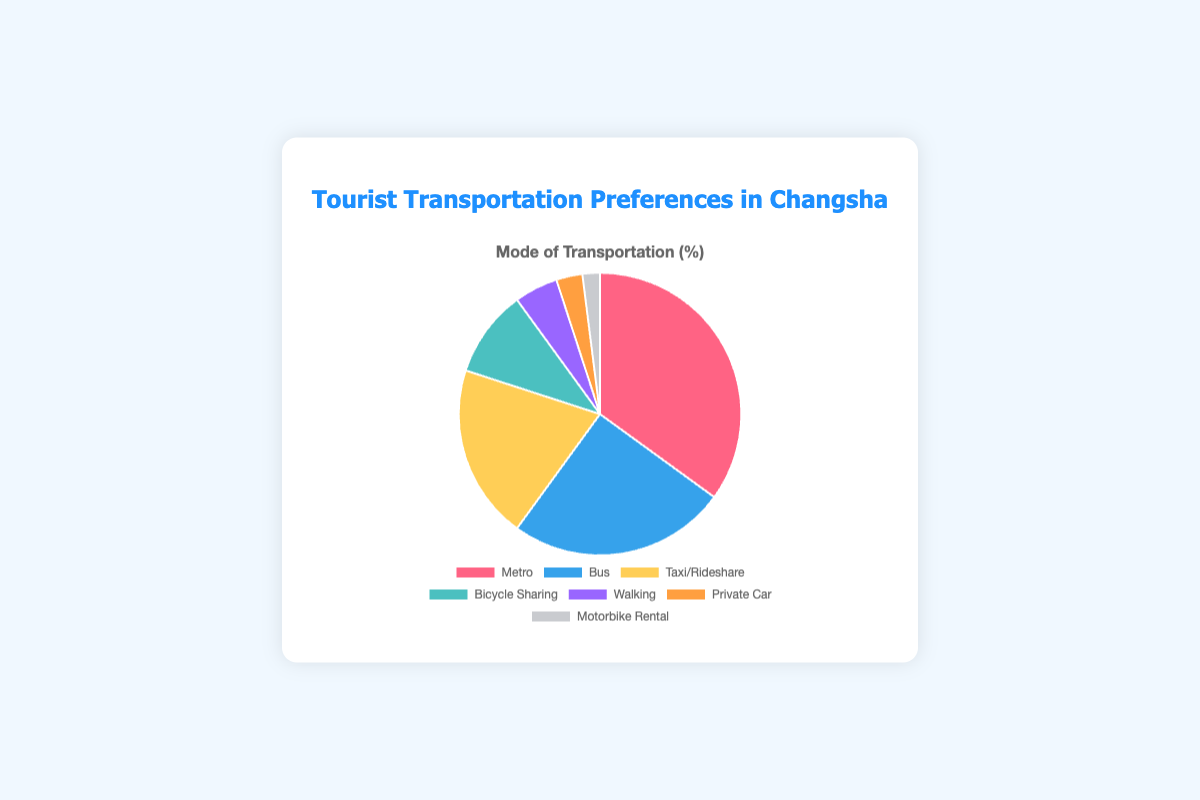What percentage of tourists use Metro and Bus combined? Add the percentage for Metro (35%) and Bus (25%): 35 + 25 = 60.
Answer: 60% Which mode of transportation is least preferred by tourists? Look for the transportation mode with the smallest percentage. Motorbike Rental has the smallest percentage at 2%.
Answer: Motorbike Rental Which transportation mode has a higher percentage, Taxi/Rideshare or Bus? Compare the percentages: Taxi/Rideshare (20%) and Bus (25%). Bus has a higher percentage.
Answer: Bus How much more popular is Metro compared to Walking? Subtract the percentage for Walking (5%) from the percentage for Metro (35%): 35 - 5 = 30.
Answer: 30% What is the combined percentage of tourists using either Metro, Bus, or Taxi/Rideshare? Add the percentages for Metro (35%), Bus (25%), and Taxi/Rideshare (20%): 35 + 25 + 20 = 80.
Answer: 80% Is the percentage of tourists using Private Car greater than those using Bicycle Sharing? Compare the percentages: Private Car (3%) and Bicycle Sharing (10%). Bicycle Sharing has a higher percentage.
Answer: No What percentage of tourists use modes of transportation other than Metro and Bus? First, find the combined percentage for Metro and Bus (35% + 25% = 60%). Then, subtract from 100%: 100 - 60 = 40.
Answer: 40% How does the popularity of Bicycle Sharing compare to Walking? Bicycle Sharing has a percentage of 10%, while Walking has 5%. Bicycle Sharing is twice as popular as Walking.
Answer: Bicycle Sharing is more popular If you were to group Private Car and Motorbike Rental into a single "Private Transport" category, what would its percentage be? Add the percentages for Private Car (3%) and Motorbike Rental (2%): 3 + 2 = 5.
Answer: 5% What is the average percentage use of all transportation modes? Add all percentages, then divide by the number of modes: (35 + 25 + 20 + 10 + 5 + 3 + 2) = 100. There are 7 modes. Average is 100 / 7 ≈ 14.29.
Answer: Approximately 14.29% 